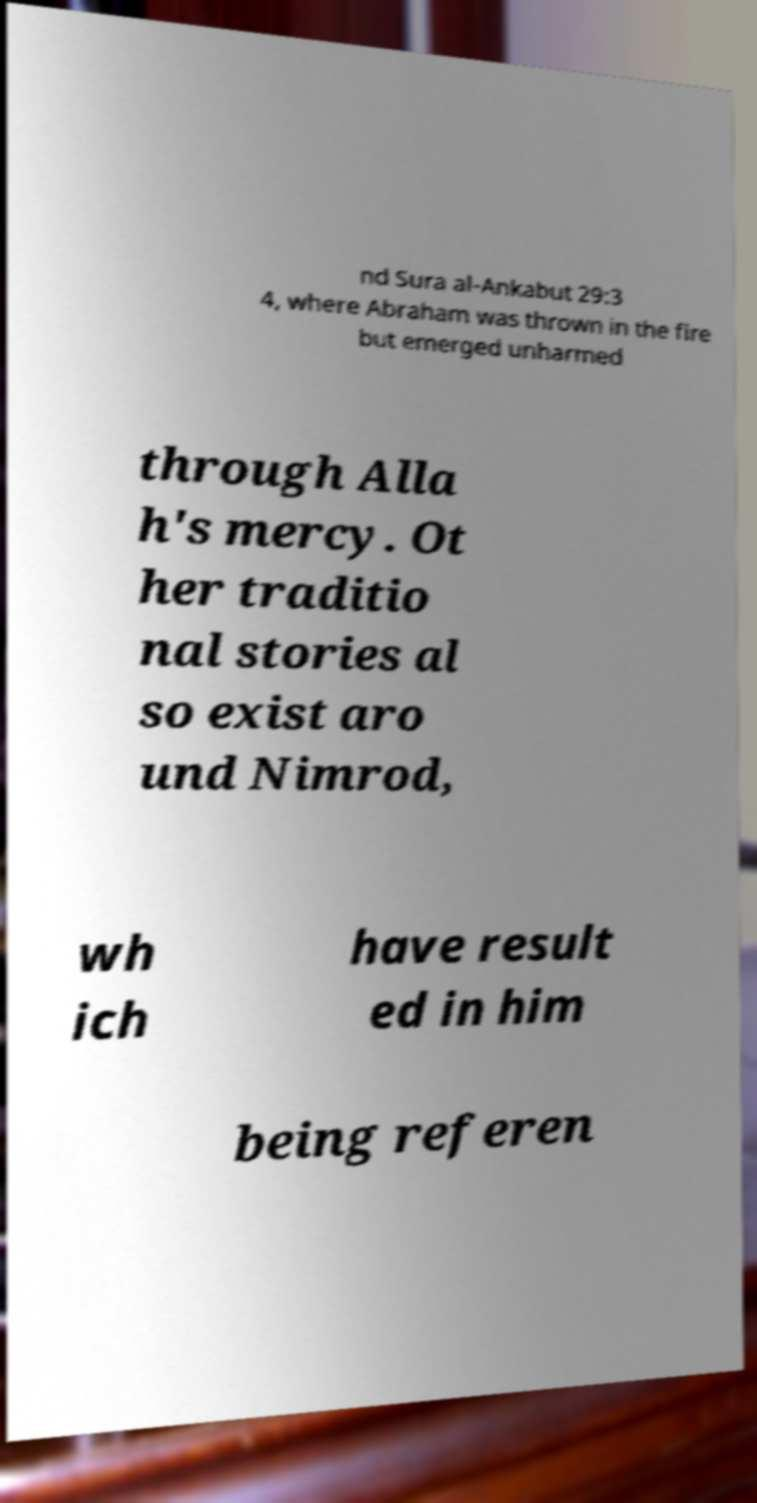Could you extract and type out the text from this image? nd Sura al-Ankabut 29:3 4, where Abraham was thrown in the fire but emerged unharmed through Alla h's mercy. Ot her traditio nal stories al so exist aro und Nimrod, wh ich have result ed in him being referen 